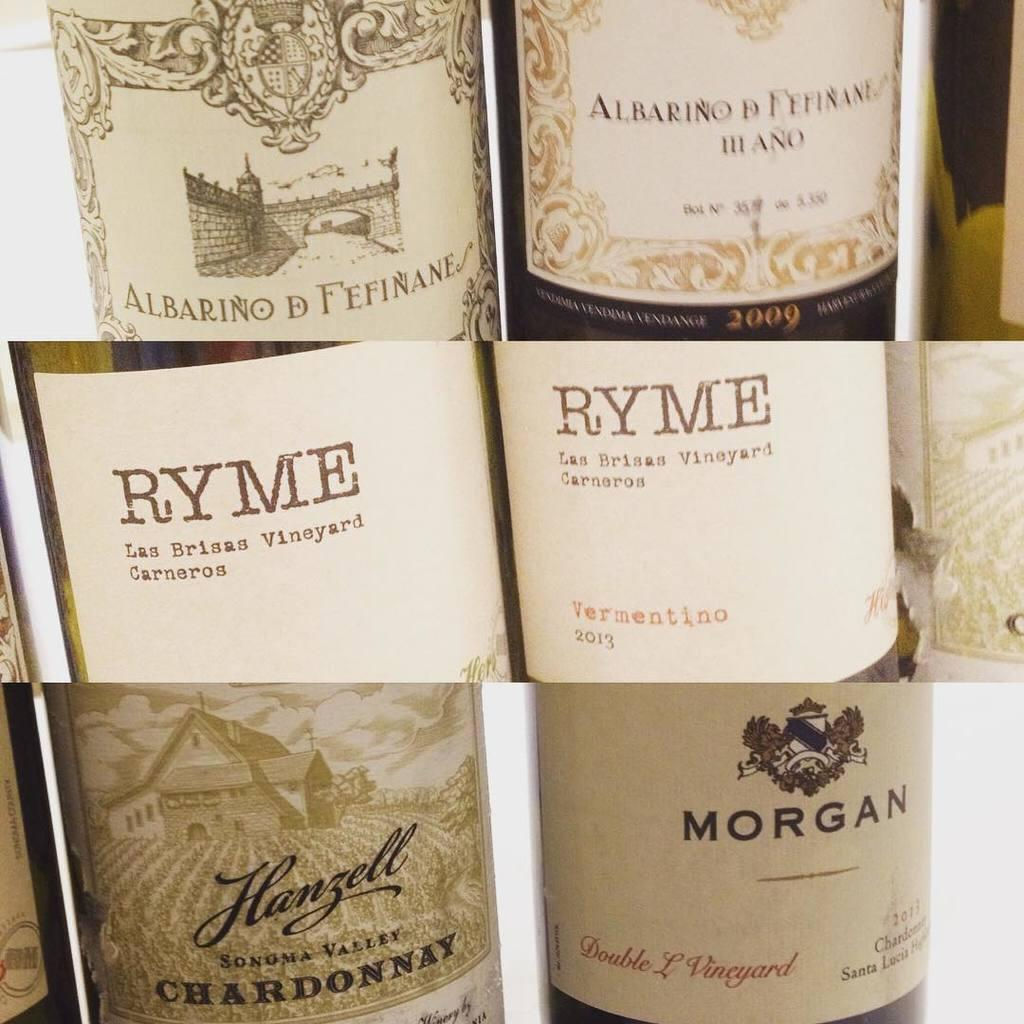<image>
Create a compact narrative representing the image presented. Bottle with label that says the word RYME on it. 